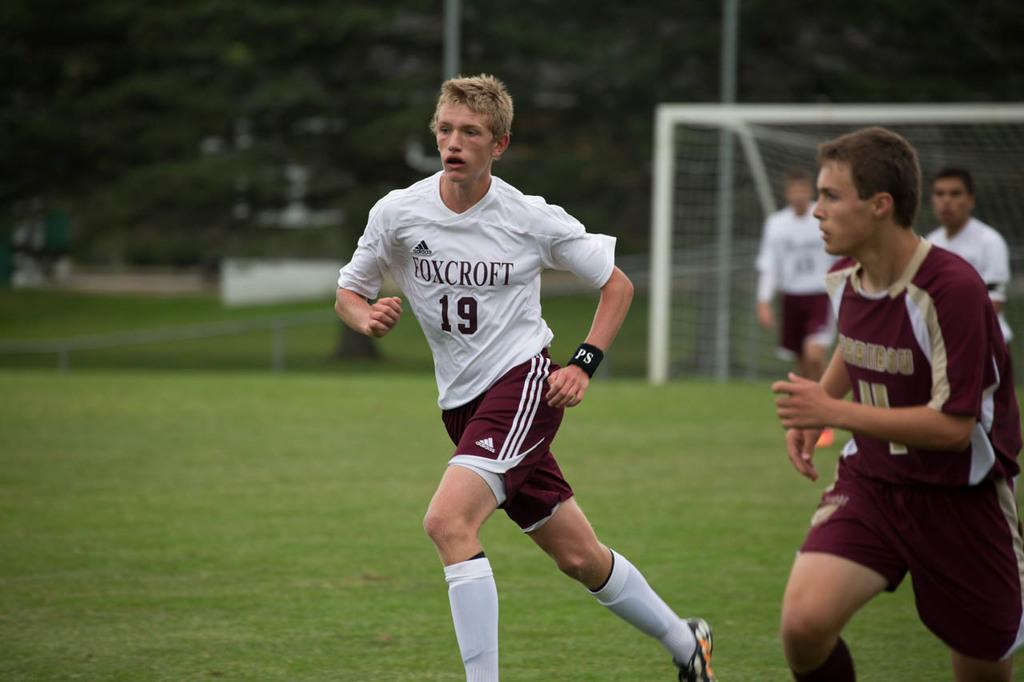<image>
Summarize the visual content of the image. A Foxcroft player wearing jersey number 19 runs to the ball during a soccer game. 